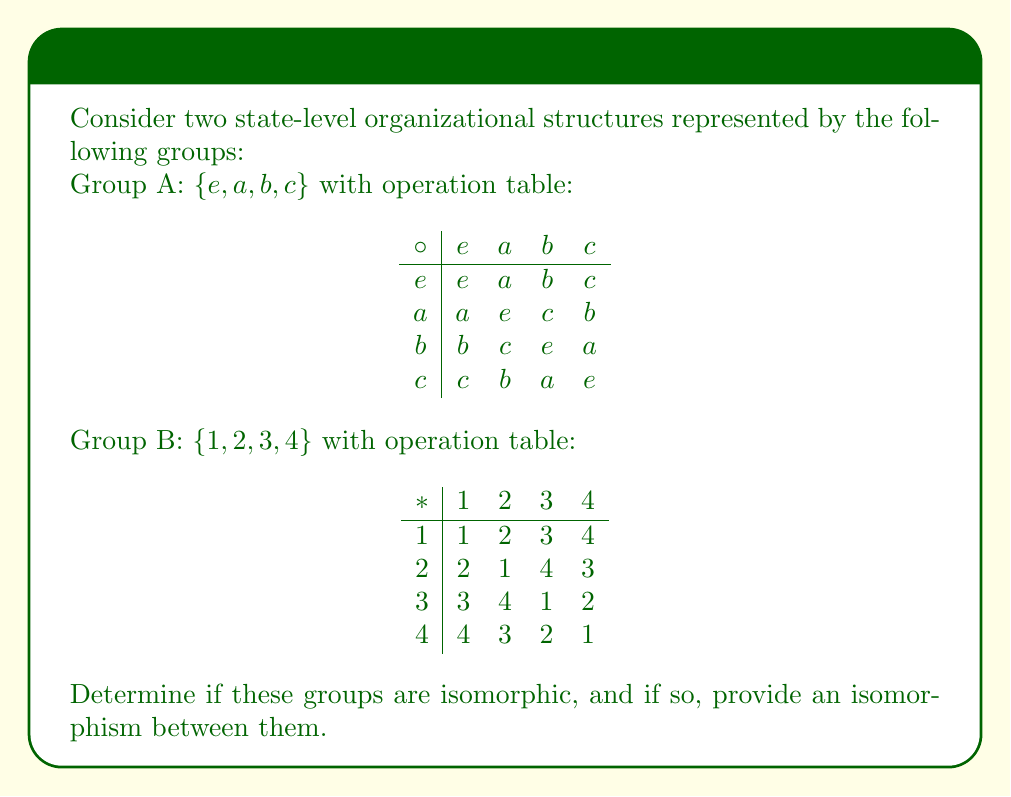Teach me how to tackle this problem. To determine if the groups are isomorphic, we'll follow these steps:

1) First, we note that both groups have the same order (4 elements), which is a necessary but not sufficient condition for isomorphism.

2) Next, we'll examine the structure of each group:
   - Both groups have an identity element (e in A, 1 in B).
   - In both groups, every element is its own inverse.
   - Both groups are non-abelian (not commutative).

3) The cycle structure of the elements in both groups is identical:
   - One element of order 1 (identity)
   - Three elements of order 2

4) Given these structural similarities, we can construct an isomorphism $\phi: A \to B$ as follows:

   $\phi(e) = 1$ (mapping identity to identity)
   $\phi(a) = 2$
   $\phi(b) = 3$
   $\phi(c) = 4$

5) To verify this is an isomorphism, we need to check that it preserves the group operation. For example:

   $\phi(a \circ b) = \phi(c) = 4$
   $\phi(a) * \phi(b) = 2 * 3 = 4$

   Similar checks can be performed for all pairs of elements.

6) Since we've found a bijective homomorphism between the groups, they are isomorphic.
Answer: Yes, isomorphic. $\phi: A \to B$ with $\phi(e) = 1$, $\phi(a) = 2$, $\phi(b) = 3$, $\phi(c) = 4$. 